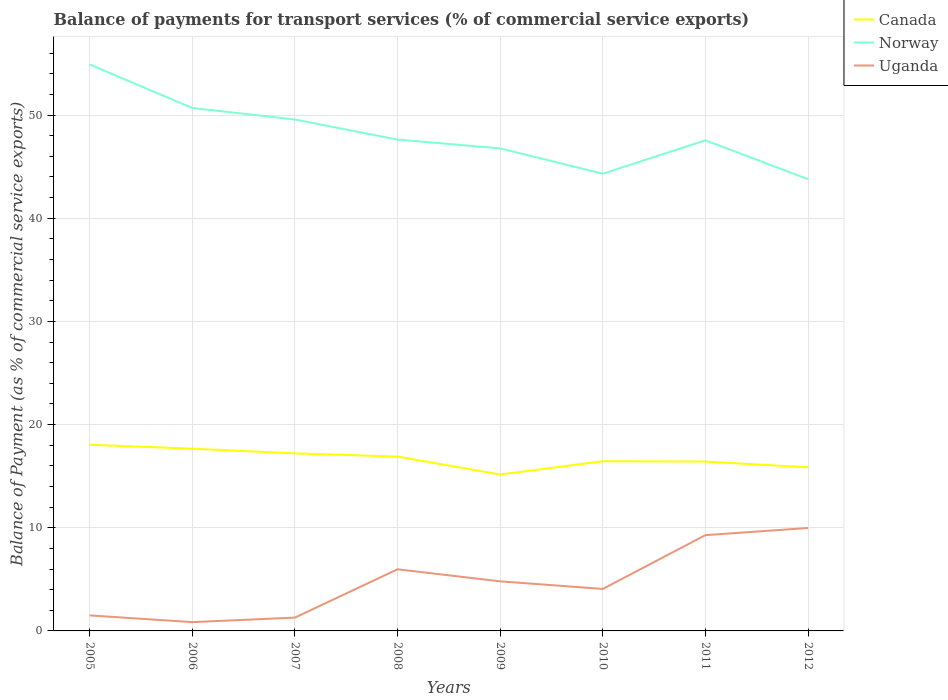Is the number of lines equal to the number of legend labels?
Offer a terse response. Yes. Across all years, what is the maximum balance of payments for transport services in Uganda?
Give a very brief answer. 0.85. In which year was the balance of payments for transport services in Norway maximum?
Provide a short and direct response. 2012. What is the total balance of payments for transport services in Norway in the graph?
Provide a short and direct response. 11.12. What is the difference between the highest and the second highest balance of payments for transport services in Norway?
Your answer should be very brief. 11.12. What is the difference between the highest and the lowest balance of payments for transport services in Uganda?
Offer a very short reply. 4. Is the balance of payments for transport services in Canada strictly greater than the balance of payments for transport services in Uganda over the years?
Provide a short and direct response. No. How many years are there in the graph?
Make the answer very short. 8. What is the difference between two consecutive major ticks on the Y-axis?
Make the answer very short. 10. How are the legend labels stacked?
Your response must be concise. Vertical. What is the title of the graph?
Provide a succinct answer. Balance of payments for transport services (% of commercial service exports). What is the label or title of the X-axis?
Offer a terse response. Years. What is the label or title of the Y-axis?
Your answer should be very brief. Balance of Payment (as % of commercial service exports). What is the Balance of Payment (as % of commercial service exports) of Canada in 2005?
Your answer should be very brief. 18.05. What is the Balance of Payment (as % of commercial service exports) in Norway in 2005?
Offer a terse response. 54.91. What is the Balance of Payment (as % of commercial service exports) in Uganda in 2005?
Give a very brief answer. 1.51. What is the Balance of Payment (as % of commercial service exports) of Canada in 2006?
Your answer should be compact. 17.66. What is the Balance of Payment (as % of commercial service exports) in Norway in 2006?
Provide a short and direct response. 50.69. What is the Balance of Payment (as % of commercial service exports) in Uganda in 2006?
Offer a very short reply. 0.85. What is the Balance of Payment (as % of commercial service exports) in Canada in 2007?
Your answer should be very brief. 17.21. What is the Balance of Payment (as % of commercial service exports) of Norway in 2007?
Your answer should be very brief. 49.57. What is the Balance of Payment (as % of commercial service exports) of Uganda in 2007?
Offer a very short reply. 1.29. What is the Balance of Payment (as % of commercial service exports) of Canada in 2008?
Your answer should be very brief. 16.9. What is the Balance of Payment (as % of commercial service exports) of Norway in 2008?
Provide a succinct answer. 47.63. What is the Balance of Payment (as % of commercial service exports) of Uganda in 2008?
Make the answer very short. 5.97. What is the Balance of Payment (as % of commercial service exports) in Canada in 2009?
Give a very brief answer. 15.16. What is the Balance of Payment (as % of commercial service exports) of Norway in 2009?
Provide a succinct answer. 46.77. What is the Balance of Payment (as % of commercial service exports) in Uganda in 2009?
Your response must be concise. 4.81. What is the Balance of Payment (as % of commercial service exports) of Canada in 2010?
Provide a short and direct response. 16.45. What is the Balance of Payment (as % of commercial service exports) in Norway in 2010?
Make the answer very short. 44.32. What is the Balance of Payment (as % of commercial service exports) in Uganda in 2010?
Give a very brief answer. 4.07. What is the Balance of Payment (as % of commercial service exports) in Canada in 2011?
Offer a very short reply. 16.42. What is the Balance of Payment (as % of commercial service exports) in Norway in 2011?
Offer a terse response. 47.55. What is the Balance of Payment (as % of commercial service exports) of Uganda in 2011?
Your answer should be very brief. 9.28. What is the Balance of Payment (as % of commercial service exports) of Canada in 2012?
Keep it short and to the point. 15.86. What is the Balance of Payment (as % of commercial service exports) of Norway in 2012?
Provide a succinct answer. 43.79. What is the Balance of Payment (as % of commercial service exports) of Uganda in 2012?
Ensure brevity in your answer.  9.98. Across all years, what is the maximum Balance of Payment (as % of commercial service exports) in Canada?
Provide a short and direct response. 18.05. Across all years, what is the maximum Balance of Payment (as % of commercial service exports) in Norway?
Your answer should be compact. 54.91. Across all years, what is the maximum Balance of Payment (as % of commercial service exports) of Uganda?
Your answer should be very brief. 9.98. Across all years, what is the minimum Balance of Payment (as % of commercial service exports) of Canada?
Provide a short and direct response. 15.16. Across all years, what is the minimum Balance of Payment (as % of commercial service exports) of Norway?
Make the answer very short. 43.79. Across all years, what is the minimum Balance of Payment (as % of commercial service exports) in Uganda?
Keep it short and to the point. 0.85. What is the total Balance of Payment (as % of commercial service exports) of Canada in the graph?
Make the answer very short. 133.71. What is the total Balance of Payment (as % of commercial service exports) in Norway in the graph?
Offer a very short reply. 385.22. What is the total Balance of Payment (as % of commercial service exports) of Uganda in the graph?
Provide a short and direct response. 37.76. What is the difference between the Balance of Payment (as % of commercial service exports) in Canada in 2005 and that in 2006?
Your answer should be very brief. 0.39. What is the difference between the Balance of Payment (as % of commercial service exports) in Norway in 2005 and that in 2006?
Offer a terse response. 4.22. What is the difference between the Balance of Payment (as % of commercial service exports) of Uganda in 2005 and that in 2006?
Give a very brief answer. 0.65. What is the difference between the Balance of Payment (as % of commercial service exports) in Canada in 2005 and that in 2007?
Provide a succinct answer. 0.84. What is the difference between the Balance of Payment (as % of commercial service exports) of Norway in 2005 and that in 2007?
Your response must be concise. 5.33. What is the difference between the Balance of Payment (as % of commercial service exports) of Uganda in 2005 and that in 2007?
Keep it short and to the point. 0.21. What is the difference between the Balance of Payment (as % of commercial service exports) in Canada in 2005 and that in 2008?
Ensure brevity in your answer.  1.15. What is the difference between the Balance of Payment (as % of commercial service exports) of Norway in 2005 and that in 2008?
Make the answer very short. 7.28. What is the difference between the Balance of Payment (as % of commercial service exports) of Uganda in 2005 and that in 2008?
Offer a terse response. -4.47. What is the difference between the Balance of Payment (as % of commercial service exports) in Canada in 2005 and that in 2009?
Provide a succinct answer. 2.89. What is the difference between the Balance of Payment (as % of commercial service exports) of Norway in 2005 and that in 2009?
Your answer should be compact. 8.13. What is the difference between the Balance of Payment (as % of commercial service exports) in Uganda in 2005 and that in 2009?
Offer a very short reply. -3.3. What is the difference between the Balance of Payment (as % of commercial service exports) in Canada in 2005 and that in 2010?
Make the answer very short. 1.6. What is the difference between the Balance of Payment (as % of commercial service exports) of Norway in 2005 and that in 2010?
Offer a terse response. 10.59. What is the difference between the Balance of Payment (as % of commercial service exports) in Uganda in 2005 and that in 2010?
Provide a short and direct response. -2.56. What is the difference between the Balance of Payment (as % of commercial service exports) of Canada in 2005 and that in 2011?
Keep it short and to the point. 1.63. What is the difference between the Balance of Payment (as % of commercial service exports) of Norway in 2005 and that in 2011?
Your answer should be compact. 7.35. What is the difference between the Balance of Payment (as % of commercial service exports) in Uganda in 2005 and that in 2011?
Offer a terse response. -7.78. What is the difference between the Balance of Payment (as % of commercial service exports) in Canada in 2005 and that in 2012?
Make the answer very short. 2.19. What is the difference between the Balance of Payment (as % of commercial service exports) in Norway in 2005 and that in 2012?
Keep it short and to the point. 11.12. What is the difference between the Balance of Payment (as % of commercial service exports) in Uganda in 2005 and that in 2012?
Your answer should be compact. -8.47. What is the difference between the Balance of Payment (as % of commercial service exports) of Canada in 2006 and that in 2007?
Offer a very short reply. 0.45. What is the difference between the Balance of Payment (as % of commercial service exports) in Norway in 2006 and that in 2007?
Offer a very short reply. 1.12. What is the difference between the Balance of Payment (as % of commercial service exports) in Uganda in 2006 and that in 2007?
Ensure brevity in your answer.  -0.44. What is the difference between the Balance of Payment (as % of commercial service exports) of Canada in 2006 and that in 2008?
Provide a short and direct response. 0.76. What is the difference between the Balance of Payment (as % of commercial service exports) of Norway in 2006 and that in 2008?
Your answer should be compact. 3.06. What is the difference between the Balance of Payment (as % of commercial service exports) in Uganda in 2006 and that in 2008?
Your response must be concise. -5.12. What is the difference between the Balance of Payment (as % of commercial service exports) in Canada in 2006 and that in 2009?
Provide a succinct answer. 2.5. What is the difference between the Balance of Payment (as % of commercial service exports) in Norway in 2006 and that in 2009?
Make the answer very short. 3.92. What is the difference between the Balance of Payment (as % of commercial service exports) in Uganda in 2006 and that in 2009?
Give a very brief answer. -3.95. What is the difference between the Balance of Payment (as % of commercial service exports) in Canada in 2006 and that in 2010?
Your answer should be compact. 1.21. What is the difference between the Balance of Payment (as % of commercial service exports) of Norway in 2006 and that in 2010?
Provide a short and direct response. 6.37. What is the difference between the Balance of Payment (as % of commercial service exports) of Uganda in 2006 and that in 2010?
Your answer should be compact. -3.22. What is the difference between the Balance of Payment (as % of commercial service exports) of Canada in 2006 and that in 2011?
Make the answer very short. 1.25. What is the difference between the Balance of Payment (as % of commercial service exports) of Norway in 2006 and that in 2011?
Ensure brevity in your answer.  3.13. What is the difference between the Balance of Payment (as % of commercial service exports) in Uganda in 2006 and that in 2011?
Your response must be concise. -8.43. What is the difference between the Balance of Payment (as % of commercial service exports) of Canada in 2006 and that in 2012?
Your answer should be very brief. 1.8. What is the difference between the Balance of Payment (as % of commercial service exports) in Norway in 2006 and that in 2012?
Make the answer very short. 6.9. What is the difference between the Balance of Payment (as % of commercial service exports) in Uganda in 2006 and that in 2012?
Provide a short and direct response. -9.13. What is the difference between the Balance of Payment (as % of commercial service exports) of Canada in 2007 and that in 2008?
Ensure brevity in your answer.  0.31. What is the difference between the Balance of Payment (as % of commercial service exports) of Norway in 2007 and that in 2008?
Offer a terse response. 1.94. What is the difference between the Balance of Payment (as % of commercial service exports) in Uganda in 2007 and that in 2008?
Make the answer very short. -4.68. What is the difference between the Balance of Payment (as % of commercial service exports) of Canada in 2007 and that in 2009?
Your answer should be very brief. 2.05. What is the difference between the Balance of Payment (as % of commercial service exports) in Norway in 2007 and that in 2009?
Provide a succinct answer. 2.8. What is the difference between the Balance of Payment (as % of commercial service exports) of Uganda in 2007 and that in 2009?
Provide a short and direct response. -3.52. What is the difference between the Balance of Payment (as % of commercial service exports) of Canada in 2007 and that in 2010?
Your answer should be compact. 0.76. What is the difference between the Balance of Payment (as % of commercial service exports) of Norway in 2007 and that in 2010?
Your response must be concise. 5.25. What is the difference between the Balance of Payment (as % of commercial service exports) of Uganda in 2007 and that in 2010?
Make the answer very short. -2.78. What is the difference between the Balance of Payment (as % of commercial service exports) of Canada in 2007 and that in 2011?
Keep it short and to the point. 0.79. What is the difference between the Balance of Payment (as % of commercial service exports) in Norway in 2007 and that in 2011?
Give a very brief answer. 2.02. What is the difference between the Balance of Payment (as % of commercial service exports) of Uganda in 2007 and that in 2011?
Make the answer very short. -7.99. What is the difference between the Balance of Payment (as % of commercial service exports) of Canada in 2007 and that in 2012?
Your answer should be compact. 1.35. What is the difference between the Balance of Payment (as % of commercial service exports) of Norway in 2007 and that in 2012?
Make the answer very short. 5.78. What is the difference between the Balance of Payment (as % of commercial service exports) in Uganda in 2007 and that in 2012?
Your answer should be very brief. -8.69. What is the difference between the Balance of Payment (as % of commercial service exports) in Canada in 2008 and that in 2009?
Keep it short and to the point. 1.74. What is the difference between the Balance of Payment (as % of commercial service exports) in Norway in 2008 and that in 2009?
Provide a succinct answer. 0.86. What is the difference between the Balance of Payment (as % of commercial service exports) in Uganda in 2008 and that in 2009?
Provide a succinct answer. 1.17. What is the difference between the Balance of Payment (as % of commercial service exports) of Canada in 2008 and that in 2010?
Provide a succinct answer. 0.45. What is the difference between the Balance of Payment (as % of commercial service exports) in Norway in 2008 and that in 2010?
Ensure brevity in your answer.  3.31. What is the difference between the Balance of Payment (as % of commercial service exports) of Uganda in 2008 and that in 2010?
Make the answer very short. 1.9. What is the difference between the Balance of Payment (as % of commercial service exports) of Canada in 2008 and that in 2011?
Keep it short and to the point. 0.48. What is the difference between the Balance of Payment (as % of commercial service exports) in Norway in 2008 and that in 2011?
Ensure brevity in your answer.  0.08. What is the difference between the Balance of Payment (as % of commercial service exports) in Uganda in 2008 and that in 2011?
Offer a terse response. -3.31. What is the difference between the Balance of Payment (as % of commercial service exports) of Canada in 2008 and that in 2012?
Ensure brevity in your answer.  1.04. What is the difference between the Balance of Payment (as % of commercial service exports) of Norway in 2008 and that in 2012?
Offer a very short reply. 3.84. What is the difference between the Balance of Payment (as % of commercial service exports) of Uganda in 2008 and that in 2012?
Your response must be concise. -4. What is the difference between the Balance of Payment (as % of commercial service exports) in Canada in 2009 and that in 2010?
Your answer should be very brief. -1.29. What is the difference between the Balance of Payment (as % of commercial service exports) in Norway in 2009 and that in 2010?
Give a very brief answer. 2.45. What is the difference between the Balance of Payment (as % of commercial service exports) of Uganda in 2009 and that in 2010?
Provide a succinct answer. 0.74. What is the difference between the Balance of Payment (as % of commercial service exports) of Canada in 2009 and that in 2011?
Your answer should be very brief. -1.25. What is the difference between the Balance of Payment (as % of commercial service exports) in Norway in 2009 and that in 2011?
Your answer should be very brief. -0.78. What is the difference between the Balance of Payment (as % of commercial service exports) in Uganda in 2009 and that in 2011?
Provide a short and direct response. -4.48. What is the difference between the Balance of Payment (as % of commercial service exports) of Canada in 2009 and that in 2012?
Your answer should be very brief. -0.69. What is the difference between the Balance of Payment (as % of commercial service exports) in Norway in 2009 and that in 2012?
Your answer should be compact. 2.98. What is the difference between the Balance of Payment (as % of commercial service exports) of Uganda in 2009 and that in 2012?
Make the answer very short. -5.17. What is the difference between the Balance of Payment (as % of commercial service exports) in Canada in 2010 and that in 2011?
Your answer should be very brief. 0.03. What is the difference between the Balance of Payment (as % of commercial service exports) in Norway in 2010 and that in 2011?
Provide a short and direct response. -3.24. What is the difference between the Balance of Payment (as % of commercial service exports) in Uganda in 2010 and that in 2011?
Provide a succinct answer. -5.21. What is the difference between the Balance of Payment (as % of commercial service exports) of Canada in 2010 and that in 2012?
Give a very brief answer. 0.59. What is the difference between the Balance of Payment (as % of commercial service exports) of Norway in 2010 and that in 2012?
Give a very brief answer. 0.53. What is the difference between the Balance of Payment (as % of commercial service exports) in Uganda in 2010 and that in 2012?
Keep it short and to the point. -5.91. What is the difference between the Balance of Payment (as % of commercial service exports) in Canada in 2011 and that in 2012?
Keep it short and to the point. 0.56. What is the difference between the Balance of Payment (as % of commercial service exports) of Norway in 2011 and that in 2012?
Provide a short and direct response. 3.76. What is the difference between the Balance of Payment (as % of commercial service exports) of Uganda in 2011 and that in 2012?
Give a very brief answer. -0.69. What is the difference between the Balance of Payment (as % of commercial service exports) of Canada in 2005 and the Balance of Payment (as % of commercial service exports) of Norway in 2006?
Keep it short and to the point. -32.64. What is the difference between the Balance of Payment (as % of commercial service exports) of Canada in 2005 and the Balance of Payment (as % of commercial service exports) of Uganda in 2006?
Give a very brief answer. 17.2. What is the difference between the Balance of Payment (as % of commercial service exports) of Norway in 2005 and the Balance of Payment (as % of commercial service exports) of Uganda in 2006?
Your response must be concise. 54.05. What is the difference between the Balance of Payment (as % of commercial service exports) of Canada in 2005 and the Balance of Payment (as % of commercial service exports) of Norway in 2007?
Give a very brief answer. -31.52. What is the difference between the Balance of Payment (as % of commercial service exports) of Canada in 2005 and the Balance of Payment (as % of commercial service exports) of Uganda in 2007?
Make the answer very short. 16.76. What is the difference between the Balance of Payment (as % of commercial service exports) in Norway in 2005 and the Balance of Payment (as % of commercial service exports) in Uganda in 2007?
Offer a very short reply. 53.61. What is the difference between the Balance of Payment (as % of commercial service exports) in Canada in 2005 and the Balance of Payment (as % of commercial service exports) in Norway in 2008?
Your answer should be very brief. -29.58. What is the difference between the Balance of Payment (as % of commercial service exports) in Canada in 2005 and the Balance of Payment (as % of commercial service exports) in Uganda in 2008?
Make the answer very short. 12.08. What is the difference between the Balance of Payment (as % of commercial service exports) of Norway in 2005 and the Balance of Payment (as % of commercial service exports) of Uganda in 2008?
Provide a succinct answer. 48.93. What is the difference between the Balance of Payment (as % of commercial service exports) in Canada in 2005 and the Balance of Payment (as % of commercial service exports) in Norway in 2009?
Provide a short and direct response. -28.72. What is the difference between the Balance of Payment (as % of commercial service exports) of Canada in 2005 and the Balance of Payment (as % of commercial service exports) of Uganda in 2009?
Make the answer very short. 13.24. What is the difference between the Balance of Payment (as % of commercial service exports) of Norway in 2005 and the Balance of Payment (as % of commercial service exports) of Uganda in 2009?
Keep it short and to the point. 50.1. What is the difference between the Balance of Payment (as % of commercial service exports) of Canada in 2005 and the Balance of Payment (as % of commercial service exports) of Norway in 2010?
Provide a succinct answer. -26.27. What is the difference between the Balance of Payment (as % of commercial service exports) in Canada in 2005 and the Balance of Payment (as % of commercial service exports) in Uganda in 2010?
Ensure brevity in your answer.  13.98. What is the difference between the Balance of Payment (as % of commercial service exports) in Norway in 2005 and the Balance of Payment (as % of commercial service exports) in Uganda in 2010?
Ensure brevity in your answer.  50.84. What is the difference between the Balance of Payment (as % of commercial service exports) in Canada in 2005 and the Balance of Payment (as % of commercial service exports) in Norway in 2011?
Provide a succinct answer. -29.5. What is the difference between the Balance of Payment (as % of commercial service exports) in Canada in 2005 and the Balance of Payment (as % of commercial service exports) in Uganda in 2011?
Offer a very short reply. 8.77. What is the difference between the Balance of Payment (as % of commercial service exports) in Norway in 2005 and the Balance of Payment (as % of commercial service exports) in Uganda in 2011?
Give a very brief answer. 45.62. What is the difference between the Balance of Payment (as % of commercial service exports) of Canada in 2005 and the Balance of Payment (as % of commercial service exports) of Norway in 2012?
Offer a terse response. -25.74. What is the difference between the Balance of Payment (as % of commercial service exports) in Canada in 2005 and the Balance of Payment (as % of commercial service exports) in Uganda in 2012?
Offer a very short reply. 8.07. What is the difference between the Balance of Payment (as % of commercial service exports) in Norway in 2005 and the Balance of Payment (as % of commercial service exports) in Uganda in 2012?
Your response must be concise. 44.93. What is the difference between the Balance of Payment (as % of commercial service exports) in Canada in 2006 and the Balance of Payment (as % of commercial service exports) in Norway in 2007?
Provide a short and direct response. -31.91. What is the difference between the Balance of Payment (as % of commercial service exports) in Canada in 2006 and the Balance of Payment (as % of commercial service exports) in Uganda in 2007?
Offer a terse response. 16.37. What is the difference between the Balance of Payment (as % of commercial service exports) of Norway in 2006 and the Balance of Payment (as % of commercial service exports) of Uganda in 2007?
Give a very brief answer. 49.4. What is the difference between the Balance of Payment (as % of commercial service exports) of Canada in 2006 and the Balance of Payment (as % of commercial service exports) of Norway in 2008?
Your answer should be compact. -29.97. What is the difference between the Balance of Payment (as % of commercial service exports) of Canada in 2006 and the Balance of Payment (as % of commercial service exports) of Uganda in 2008?
Your answer should be compact. 11.69. What is the difference between the Balance of Payment (as % of commercial service exports) in Norway in 2006 and the Balance of Payment (as % of commercial service exports) in Uganda in 2008?
Your answer should be very brief. 44.71. What is the difference between the Balance of Payment (as % of commercial service exports) of Canada in 2006 and the Balance of Payment (as % of commercial service exports) of Norway in 2009?
Keep it short and to the point. -29.11. What is the difference between the Balance of Payment (as % of commercial service exports) in Canada in 2006 and the Balance of Payment (as % of commercial service exports) in Uganda in 2009?
Offer a terse response. 12.86. What is the difference between the Balance of Payment (as % of commercial service exports) in Norway in 2006 and the Balance of Payment (as % of commercial service exports) in Uganda in 2009?
Your response must be concise. 45.88. What is the difference between the Balance of Payment (as % of commercial service exports) of Canada in 2006 and the Balance of Payment (as % of commercial service exports) of Norway in 2010?
Offer a terse response. -26.65. What is the difference between the Balance of Payment (as % of commercial service exports) in Canada in 2006 and the Balance of Payment (as % of commercial service exports) in Uganda in 2010?
Offer a very short reply. 13.59. What is the difference between the Balance of Payment (as % of commercial service exports) in Norway in 2006 and the Balance of Payment (as % of commercial service exports) in Uganda in 2010?
Ensure brevity in your answer.  46.62. What is the difference between the Balance of Payment (as % of commercial service exports) in Canada in 2006 and the Balance of Payment (as % of commercial service exports) in Norway in 2011?
Ensure brevity in your answer.  -29.89. What is the difference between the Balance of Payment (as % of commercial service exports) in Canada in 2006 and the Balance of Payment (as % of commercial service exports) in Uganda in 2011?
Make the answer very short. 8.38. What is the difference between the Balance of Payment (as % of commercial service exports) in Norway in 2006 and the Balance of Payment (as % of commercial service exports) in Uganda in 2011?
Make the answer very short. 41.4. What is the difference between the Balance of Payment (as % of commercial service exports) of Canada in 2006 and the Balance of Payment (as % of commercial service exports) of Norway in 2012?
Your answer should be very brief. -26.13. What is the difference between the Balance of Payment (as % of commercial service exports) in Canada in 2006 and the Balance of Payment (as % of commercial service exports) in Uganda in 2012?
Provide a succinct answer. 7.68. What is the difference between the Balance of Payment (as % of commercial service exports) in Norway in 2006 and the Balance of Payment (as % of commercial service exports) in Uganda in 2012?
Ensure brevity in your answer.  40.71. What is the difference between the Balance of Payment (as % of commercial service exports) in Canada in 2007 and the Balance of Payment (as % of commercial service exports) in Norway in 2008?
Offer a terse response. -30.42. What is the difference between the Balance of Payment (as % of commercial service exports) of Canada in 2007 and the Balance of Payment (as % of commercial service exports) of Uganda in 2008?
Offer a terse response. 11.24. What is the difference between the Balance of Payment (as % of commercial service exports) of Norway in 2007 and the Balance of Payment (as % of commercial service exports) of Uganda in 2008?
Provide a succinct answer. 43.6. What is the difference between the Balance of Payment (as % of commercial service exports) of Canada in 2007 and the Balance of Payment (as % of commercial service exports) of Norway in 2009?
Offer a terse response. -29.56. What is the difference between the Balance of Payment (as % of commercial service exports) in Canada in 2007 and the Balance of Payment (as % of commercial service exports) in Uganda in 2009?
Provide a succinct answer. 12.4. What is the difference between the Balance of Payment (as % of commercial service exports) of Norway in 2007 and the Balance of Payment (as % of commercial service exports) of Uganda in 2009?
Make the answer very short. 44.76. What is the difference between the Balance of Payment (as % of commercial service exports) in Canada in 2007 and the Balance of Payment (as % of commercial service exports) in Norway in 2010?
Make the answer very short. -27.11. What is the difference between the Balance of Payment (as % of commercial service exports) in Canada in 2007 and the Balance of Payment (as % of commercial service exports) in Uganda in 2010?
Offer a terse response. 13.14. What is the difference between the Balance of Payment (as % of commercial service exports) in Norway in 2007 and the Balance of Payment (as % of commercial service exports) in Uganda in 2010?
Make the answer very short. 45.5. What is the difference between the Balance of Payment (as % of commercial service exports) of Canada in 2007 and the Balance of Payment (as % of commercial service exports) of Norway in 2011?
Ensure brevity in your answer.  -30.34. What is the difference between the Balance of Payment (as % of commercial service exports) in Canada in 2007 and the Balance of Payment (as % of commercial service exports) in Uganda in 2011?
Your answer should be very brief. 7.93. What is the difference between the Balance of Payment (as % of commercial service exports) in Norway in 2007 and the Balance of Payment (as % of commercial service exports) in Uganda in 2011?
Provide a succinct answer. 40.29. What is the difference between the Balance of Payment (as % of commercial service exports) of Canada in 2007 and the Balance of Payment (as % of commercial service exports) of Norway in 2012?
Your response must be concise. -26.58. What is the difference between the Balance of Payment (as % of commercial service exports) in Canada in 2007 and the Balance of Payment (as % of commercial service exports) in Uganda in 2012?
Give a very brief answer. 7.23. What is the difference between the Balance of Payment (as % of commercial service exports) in Norway in 2007 and the Balance of Payment (as % of commercial service exports) in Uganda in 2012?
Your answer should be compact. 39.59. What is the difference between the Balance of Payment (as % of commercial service exports) of Canada in 2008 and the Balance of Payment (as % of commercial service exports) of Norway in 2009?
Make the answer very short. -29.87. What is the difference between the Balance of Payment (as % of commercial service exports) of Canada in 2008 and the Balance of Payment (as % of commercial service exports) of Uganda in 2009?
Offer a very short reply. 12.09. What is the difference between the Balance of Payment (as % of commercial service exports) of Norway in 2008 and the Balance of Payment (as % of commercial service exports) of Uganda in 2009?
Provide a short and direct response. 42.82. What is the difference between the Balance of Payment (as % of commercial service exports) in Canada in 2008 and the Balance of Payment (as % of commercial service exports) in Norway in 2010?
Your answer should be compact. -27.42. What is the difference between the Balance of Payment (as % of commercial service exports) of Canada in 2008 and the Balance of Payment (as % of commercial service exports) of Uganda in 2010?
Provide a succinct answer. 12.83. What is the difference between the Balance of Payment (as % of commercial service exports) of Norway in 2008 and the Balance of Payment (as % of commercial service exports) of Uganda in 2010?
Provide a short and direct response. 43.56. What is the difference between the Balance of Payment (as % of commercial service exports) in Canada in 2008 and the Balance of Payment (as % of commercial service exports) in Norway in 2011?
Make the answer very short. -30.65. What is the difference between the Balance of Payment (as % of commercial service exports) of Canada in 2008 and the Balance of Payment (as % of commercial service exports) of Uganda in 2011?
Make the answer very short. 7.62. What is the difference between the Balance of Payment (as % of commercial service exports) of Norway in 2008 and the Balance of Payment (as % of commercial service exports) of Uganda in 2011?
Your response must be concise. 38.34. What is the difference between the Balance of Payment (as % of commercial service exports) in Canada in 2008 and the Balance of Payment (as % of commercial service exports) in Norway in 2012?
Provide a succinct answer. -26.89. What is the difference between the Balance of Payment (as % of commercial service exports) in Canada in 2008 and the Balance of Payment (as % of commercial service exports) in Uganda in 2012?
Provide a short and direct response. 6.92. What is the difference between the Balance of Payment (as % of commercial service exports) of Norway in 2008 and the Balance of Payment (as % of commercial service exports) of Uganda in 2012?
Your answer should be very brief. 37.65. What is the difference between the Balance of Payment (as % of commercial service exports) of Canada in 2009 and the Balance of Payment (as % of commercial service exports) of Norway in 2010?
Provide a succinct answer. -29.15. What is the difference between the Balance of Payment (as % of commercial service exports) of Canada in 2009 and the Balance of Payment (as % of commercial service exports) of Uganda in 2010?
Offer a very short reply. 11.1. What is the difference between the Balance of Payment (as % of commercial service exports) in Norway in 2009 and the Balance of Payment (as % of commercial service exports) in Uganda in 2010?
Provide a succinct answer. 42.7. What is the difference between the Balance of Payment (as % of commercial service exports) of Canada in 2009 and the Balance of Payment (as % of commercial service exports) of Norway in 2011?
Ensure brevity in your answer.  -32.39. What is the difference between the Balance of Payment (as % of commercial service exports) in Canada in 2009 and the Balance of Payment (as % of commercial service exports) in Uganda in 2011?
Your answer should be very brief. 5.88. What is the difference between the Balance of Payment (as % of commercial service exports) of Norway in 2009 and the Balance of Payment (as % of commercial service exports) of Uganda in 2011?
Provide a short and direct response. 37.49. What is the difference between the Balance of Payment (as % of commercial service exports) in Canada in 2009 and the Balance of Payment (as % of commercial service exports) in Norway in 2012?
Your answer should be very brief. -28.63. What is the difference between the Balance of Payment (as % of commercial service exports) in Canada in 2009 and the Balance of Payment (as % of commercial service exports) in Uganda in 2012?
Provide a short and direct response. 5.19. What is the difference between the Balance of Payment (as % of commercial service exports) in Norway in 2009 and the Balance of Payment (as % of commercial service exports) in Uganda in 2012?
Your answer should be compact. 36.79. What is the difference between the Balance of Payment (as % of commercial service exports) in Canada in 2010 and the Balance of Payment (as % of commercial service exports) in Norway in 2011?
Offer a terse response. -31.1. What is the difference between the Balance of Payment (as % of commercial service exports) of Canada in 2010 and the Balance of Payment (as % of commercial service exports) of Uganda in 2011?
Ensure brevity in your answer.  7.17. What is the difference between the Balance of Payment (as % of commercial service exports) in Norway in 2010 and the Balance of Payment (as % of commercial service exports) in Uganda in 2011?
Your answer should be compact. 35.03. What is the difference between the Balance of Payment (as % of commercial service exports) in Canada in 2010 and the Balance of Payment (as % of commercial service exports) in Norway in 2012?
Provide a short and direct response. -27.34. What is the difference between the Balance of Payment (as % of commercial service exports) of Canada in 2010 and the Balance of Payment (as % of commercial service exports) of Uganda in 2012?
Ensure brevity in your answer.  6.47. What is the difference between the Balance of Payment (as % of commercial service exports) in Norway in 2010 and the Balance of Payment (as % of commercial service exports) in Uganda in 2012?
Provide a short and direct response. 34.34. What is the difference between the Balance of Payment (as % of commercial service exports) of Canada in 2011 and the Balance of Payment (as % of commercial service exports) of Norway in 2012?
Your response must be concise. -27.37. What is the difference between the Balance of Payment (as % of commercial service exports) of Canada in 2011 and the Balance of Payment (as % of commercial service exports) of Uganda in 2012?
Offer a very short reply. 6.44. What is the difference between the Balance of Payment (as % of commercial service exports) of Norway in 2011 and the Balance of Payment (as % of commercial service exports) of Uganda in 2012?
Ensure brevity in your answer.  37.58. What is the average Balance of Payment (as % of commercial service exports) in Canada per year?
Your response must be concise. 16.71. What is the average Balance of Payment (as % of commercial service exports) of Norway per year?
Offer a very short reply. 48.15. What is the average Balance of Payment (as % of commercial service exports) of Uganda per year?
Your answer should be compact. 4.72. In the year 2005, what is the difference between the Balance of Payment (as % of commercial service exports) in Canada and Balance of Payment (as % of commercial service exports) in Norway?
Ensure brevity in your answer.  -36.86. In the year 2005, what is the difference between the Balance of Payment (as % of commercial service exports) of Canada and Balance of Payment (as % of commercial service exports) of Uganda?
Ensure brevity in your answer.  16.54. In the year 2005, what is the difference between the Balance of Payment (as % of commercial service exports) of Norway and Balance of Payment (as % of commercial service exports) of Uganda?
Give a very brief answer. 53.4. In the year 2006, what is the difference between the Balance of Payment (as % of commercial service exports) in Canada and Balance of Payment (as % of commercial service exports) in Norway?
Your answer should be very brief. -33.02. In the year 2006, what is the difference between the Balance of Payment (as % of commercial service exports) in Canada and Balance of Payment (as % of commercial service exports) in Uganda?
Make the answer very short. 16.81. In the year 2006, what is the difference between the Balance of Payment (as % of commercial service exports) of Norway and Balance of Payment (as % of commercial service exports) of Uganda?
Offer a terse response. 49.83. In the year 2007, what is the difference between the Balance of Payment (as % of commercial service exports) of Canada and Balance of Payment (as % of commercial service exports) of Norway?
Your response must be concise. -32.36. In the year 2007, what is the difference between the Balance of Payment (as % of commercial service exports) of Canada and Balance of Payment (as % of commercial service exports) of Uganda?
Offer a very short reply. 15.92. In the year 2007, what is the difference between the Balance of Payment (as % of commercial service exports) of Norway and Balance of Payment (as % of commercial service exports) of Uganda?
Keep it short and to the point. 48.28. In the year 2008, what is the difference between the Balance of Payment (as % of commercial service exports) of Canada and Balance of Payment (as % of commercial service exports) of Norway?
Provide a short and direct response. -30.73. In the year 2008, what is the difference between the Balance of Payment (as % of commercial service exports) in Canada and Balance of Payment (as % of commercial service exports) in Uganda?
Your answer should be compact. 10.93. In the year 2008, what is the difference between the Balance of Payment (as % of commercial service exports) in Norway and Balance of Payment (as % of commercial service exports) in Uganda?
Ensure brevity in your answer.  41.65. In the year 2009, what is the difference between the Balance of Payment (as % of commercial service exports) in Canada and Balance of Payment (as % of commercial service exports) in Norway?
Your answer should be compact. -31.61. In the year 2009, what is the difference between the Balance of Payment (as % of commercial service exports) in Canada and Balance of Payment (as % of commercial service exports) in Uganda?
Your response must be concise. 10.36. In the year 2009, what is the difference between the Balance of Payment (as % of commercial service exports) of Norway and Balance of Payment (as % of commercial service exports) of Uganda?
Keep it short and to the point. 41.97. In the year 2010, what is the difference between the Balance of Payment (as % of commercial service exports) in Canada and Balance of Payment (as % of commercial service exports) in Norway?
Provide a succinct answer. -27.87. In the year 2010, what is the difference between the Balance of Payment (as % of commercial service exports) in Canada and Balance of Payment (as % of commercial service exports) in Uganda?
Ensure brevity in your answer.  12.38. In the year 2010, what is the difference between the Balance of Payment (as % of commercial service exports) of Norway and Balance of Payment (as % of commercial service exports) of Uganda?
Make the answer very short. 40.25. In the year 2011, what is the difference between the Balance of Payment (as % of commercial service exports) of Canada and Balance of Payment (as % of commercial service exports) of Norway?
Offer a very short reply. -31.14. In the year 2011, what is the difference between the Balance of Payment (as % of commercial service exports) of Canada and Balance of Payment (as % of commercial service exports) of Uganda?
Provide a short and direct response. 7.13. In the year 2011, what is the difference between the Balance of Payment (as % of commercial service exports) of Norway and Balance of Payment (as % of commercial service exports) of Uganda?
Make the answer very short. 38.27. In the year 2012, what is the difference between the Balance of Payment (as % of commercial service exports) in Canada and Balance of Payment (as % of commercial service exports) in Norway?
Keep it short and to the point. -27.93. In the year 2012, what is the difference between the Balance of Payment (as % of commercial service exports) of Canada and Balance of Payment (as % of commercial service exports) of Uganda?
Give a very brief answer. 5.88. In the year 2012, what is the difference between the Balance of Payment (as % of commercial service exports) of Norway and Balance of Payment (as % of commercial service exports) of Uganda?
Give a very brief answer. 33.81. What is the ratio of the Balance of Payment (as % of commercial service exports) of Canada in 2005 to that in 2006?
Ensure brevity in your answer.  1.02. What is the ratio of the Balance of Payment (as % of commercial service exports) of Norway in 2005 to that in 2006?
Provide a succinct answer. 1.08. What is the ratio of the Balance of Payment (as % of commercial service exports) of Uganda in 2005 to that in 2006?
Provide a short and direct response. 1.77. What is the ratio of the Balance of Payment (as % of commercial service exports) in Canada in 2005 to that in 2007?
Provide a short and direct response. 1.05. What is the ratio of the Balance of Payment (as % of commercial service exports) of Norway in 2005 to that in 2007?
Your answer should be very brief. 1.11. What is the ratio of the Balance of Payment (as % of commercial service exports) of Uganda in 2005 to that in 2007?
Your response must be concise. 1.17. What is the ratio of the Balance of Payment (as % of commercial service exports) in Canada in 2005 to that in 2008?
Give a very brief answer. 1.07. What is the ratio of the Balance of Payment (as % of commercial service exports) of Norway in 2005 to that in 2008?
Keep it short and to the point. 1.15. What is the ratio of the Balance of Payment (as % of commercial service exports) in Uganda in 2005 to that in 2008?
Offer a very short reply. 0.25. What is the ratio of the Balance of Payment (as % of commercial service exports) of Canada in 2005 to that in 2009?
Provide a short and direct response. 1.19. What is the ratio of the Balance of Payment (as % of commercial service exports) of Norway in 2005 to that in 2009?
Your answer should be compact. 1.17. What is the ratio of the Balance of Payment (as % of commercial service exports) of Uganda in 2005 to that in 2009?
Provide a short and direct response. 0.31. What is the ratio of the Balance of Payment (as % of commercial service exports) of Canada in 2005 to that in 2010?
Provide a short and direct response. 1.1. What is the ratio of the Balance of Payment (as % of commercial service exports) in Norway in 2005 to that in 2010?
Provide a short and direct response. 1.24. What is the ratio of the Balance of Payment (as % of commercial service exports) in Uganda in 2005 to that in 2010?
Ensure brevity in your answer.  0.37. What is the ratio of the Balance of Payment (as % of commercial service exports) of Canada in 2005 to that in 2011?
Your answer should be compact. 1.1. What is the ratio of the Balance of Payment (as % of commercial service exports) of Norway in 2005 to that in 2011?
Your response must be concise. 1.15. What is the ratio of the Balance of Payment (as % of commercial service exports) of Uganda in 2005 to that in 2011?
Offer a terse response. 0.16. What is the ratio of the Balance of Payment (as % of commercial service exports) of Canada in 2005 to that in 2012?
Your answer should be compact. 1.14. What is the ratio of the Balance of Payment (as % of commercial service exports) in Norway in 2005 to that in 2012?
Your answer should be compact. 1.25. What is the ratio of the Balance of Payment (as % of commercial service exports) of Uganda in 2005 to that in 2012?
Your answer should be compact. 0.15. What is the ratio of the Balance of Payment (as % of commercial service exports) in Canada in 2006 to that in 2007?
Ensure brevity in your answer.  1.03. What is the ratio of the Balance of Payment (as % of commercial service exports) of Norway in 2006 to that in 2007?
Provide a short and direct response. 1.02. What is the ratio of the Balance of Payment (as % of commercial service exports) in Uganda in 2006 to that in 2007?
Make the answer very short. 0.66. What is the ratio of the Balance of Payment (as % of commercial service exports) of Canada in 2006 to that in 2008?
Keep it short and to the point. 1.05. What is the ratio of the Balance of Payment (as % of commercial service exports) of Norway in 2006 to that in 2008?
Your response must be concise. 1.06. What is the ratio of the Balance of Payment (as % of commercial service exports) of Uganda in 2006 to that in 2008?
Offer a very short reply. 0.14. What is the ratio of the Balance of Payment (as % of commercial service exports) in Canada in 2006 to that in 2009?
Give a very brief answer. 1.16. What is the ratio of the Balance of Payment (as % of commercial service exports) in Norway in 2006 to that in 2009?
Make the answer very short. 1.08. What is the ratio of the Balance of Payment (as % of commercial service exports) in Uganda in 2006 to that in 2009?
Your response must be concise. 0.18. What is the ratio of the Balance of Payment (as % of commercial service exports) of Canada in 2006 to that in 2010?
Provide a succinct answer. 1.07. What is the ratio of the Balance of Payment (as % of commercial service exports) of Norway in 2006 to that in 2010?
Keep it short and to the point. 1.14. What is the ratio of the Balance of Payment (as % of commercial service exports) in Uganda in 2006 to that in 2010?
Keep it short and to the point. 0.21. What is the ratio of the Balance of Payment (as % of commercial service exports) in Canada in 2006 to that in 2011?
Offer a very short reply. 1.08. What is the ratio of the Balance of Payment (as % of commercial service exports) in Norway in 2006 to that in 2011?
Give a very brief answer. 1.07. What is the ratio of the Balance of Payment (as % of commercial service exports) of Uganda in 2006 to that in 2011?
Your answer should be compact. 0.09. What is the ratio of the Balance of Payment (as % of commercial service exports) in Canada in 2006 to that in 2012?
Offer a very short reply. 1.11. What is the ratio of the Balance of Payment (as % of commercial service exports) of Norway in 2006 to that in 2012?
Offer a very short reply. 1.16. What is the ratio of the Balance of Payment (as % of commercial service exports) of Uganda in 2006 to that in 2012?
Keep it short and to the point. 0.09. What is the ratio of the Balance of Payment (as % of commercial service exports) of Canada in 2007 to that in 2008?
Offer a terse response. 1.02. What is the ratio of the Balance of Payment (as % of commercial service exports) of Norway in 2007 to that in 2008?
Your answer should be very brief. 1.04. What is the ratio of the Balance of Payment (as % of commercial service exports) of Uganda in 2007 to that in 2008?
Your response must be concise. 0.22. What is the ratio of the Balance of Payment (as % of commercial service exports) of Canada in 2007 to that in 2009?
Your answer should be compact. 1.13. What is the ratio of the Balance of Payment (as % of commercial service exports) of Norway in 2007 to that in 2009?
Your answer should be compact. 1.06. What is the ratio of the Balance of Payment (as % of commercial service exports) in Uganda in 2007 to that in 2009?
Make the answer very short. 0.27. What is the ratio of the Balance of Payment (as % of commercial service exports) in Canada in 2007 to that in 2010?
Give a very brief answer. 1.05. What is the ratio of the Balance of Payment (as % of commercial service exports) in Norway in 2007 to that in 2010?
Ensure brevity in your answer.  1.12. What is the ratio of the Balance of Payment (as % of commercial service exports) of Uganda in 2007 to that in 2010?
Provide a succinct answer. 0.32. What is the ratio of the Balance of Payment (as % of commercial service exports) of Canada in 2007 to that in 2011?
Keep it short and to the point. 1.05. What is the ratio of the Balance of Payment (as % of commercial service exports) in Norway in 2007 to that in 2011?
Ensure brevity in your answer.  1.04. What is the ratio of the Balance of Payment (as % of commercial service exports) of Uganda in 2007 to that in 2011?
Give a very brief answer. 0.14. What is the ratio of the Balance of Payment (as % of commercial service exports) of Canada in 2007 to that in 2012?
Ensure brevity in your answer.  1.09. What is the ratio of the Balance of Payment (as % of commercial service exports) of Norway in 2007 to that in 2012?
Keep it short and to the point. 1.13. What is the ratio of the Balance of Payment (as % of commercial service exports) of Uganda in 2007 to that in 2012?
Provide a short and direct response. 0.13. What is the ratio of the Balance of Payment (as % of commercial service exports) of Canada in 2008 to that in 2009?
Ensure brevity in your answer.  1.11. What is the ratio of the Balance of Payment (as % of commercial service exports) in Norway in 2008 to that in 2009?
Make the answer very short. 1.02. What is the ratio of the Balance of Payment (as % of commercial service exports) in Uganda in 2008 to that in 2009?
Your answer should be compact. 1.24. What is the ratio of the Balance of Payment (as % of commercial service exports) in Canada in 2008 to that in 2010?
Give a very brief answer. 1.03. What is the ratio of the Balance of Payment (as % of commercial service exports) in Norway in 2008 to that in 2010?
Your response must be concise. 1.07. What is the ratio of the Balance of Payment (as % of commercial service exports) in Uganda in 2008 to that in 2010?
Offer a very short reply. 1.47. What is the ratio of the Balance of Payment (as % of commercial service exports) of Canada in 2008 to that in 2011?
Offer a terse response. 1.03. What is the ratio of the Balance of Payment (as % of commercial service exports) of Norway in 2008 to that in 2011?
Make the answer very short. 1. What is the ratio of the Balance of Payment (as % of commercial service exports) in Uganda in 2008 to that in 2011?
Provide a short and direct response. 0.64. What is the ratio of the Balance of Payment (as % of commercial service exports) in Canada in 2008 to that in 2012?
Your answer should be very brief. 1.07. What is the ratio of the Balance of Payment (as % of commercial service exports) of Norway in 2008 to that in 2012?
Make the answer very short. 1.09. What is the ratio of the Balance of Payment (as % of commercial service exports) of Uganda in 2008 to that in 2012?
Give a very brief answer. 0.6. What is the ratio of the Balance of Payment (as % of commercial service exports) in Canada in 2009 to that in 2010?
Make the answer very short. 0.92. What is the ratio of the Balance of Payment (as % of commercial service exports) of Norway in 2009 to that in 2010?
Ensure brevity in your answer.  1.06. What is the ratio of the Balance of Payment (as % of commercial service exports) in Uganda in 2009 to that in 2010?
Your answer should be very brief. 1.18. What is the ratio of the Balance of Payment (as % of commercial service exports) in Canada in 2009 to that in 2011?
Give a very brief answer. 0.92. What is the ratio of the Balance of Payment (as % of commercial service exports) in Norway in 2009 to that in 2011?
Your response must be concise. 0.98. What is the ratio of the Balance of Payment (as % of commercial service exports) of Uganda in 2009 to that in 2011?
Make the answer very short. 0.52. What is the ratio of the Balance of Payment (as % of commercial service exports) in Canada in 2009 to that in 2012?
Keep it short and to the point. 0.96. What is the ratio of the Balance of Payment (as % of commercial service exports) of Norway in 2009 to that in 2012?
Your answer should be compact. 1.07. What is the ratio of the Balance of Payment (as % of commercial service exports) in Uganda in 2009 to that in 2012?
Ensure brevity in your answer.  0.48. What is the ratio of the Balance of Payment (as % of commercial service exports) of Norway in 2010 to that in 2011?
Provide a short and direct response. 0.93. What is the ratio of the Balance of Payment (as % of commercial service exports) in Uganda in 2010 to that in 2011?
Provide a succinct answer. 0.44. What is the ratio of the Balance of Payment (as % of commercial service exports) of Canada in 2010 to that in 2012?
Make the answer very short. 1.04. What is the ratio of the Balance of Payment (as % of commercial service exports) of Norway in 2010 to that in 2012?
Give a very brief answer. 1.01. What is the ratio of the Balance of Payment (as % of commercial service exports) in Uganda in 2010 to that in 2012?
Your answer should be very brief. 0.41. What is the ratio of the Balance of Payment (as % of commercial service exports) in Canada in 2011 to that in 2012?
Make the answer very short. 1.04. What is the ratio of the Balance of Payment (as % of commercial service exports) in Norway in 2011 to that in 2012?
Give a very brief answer. 1.09. What is the ratio of the Balance of Payment (as % of commercial service exports) of Uganda in 2011 to that in 2012?
Give a very brief answer. 0.93. What is the difference between the highest and the second highest Balance of Payment (as % of commercial service exports) in Canada?
Offer a terse response. 0.39. What is the difference between the highest and the second highest Balance of Payment (as % of commercial service exports) of Norway?
Offer a very short reply. 4.22. What is the difference between the highest and the second highest Balance of Payment (as % of commercial service exports) of Uganda?
Ensure brevity in your answer.  0.69. What is the difference between the highest and the lowest Balance of Payment (as % of commercial service exports) in Canada?
Make the answer very short. 2.89. What is the difference between the highest and the lowest Balance of Payment (as % of commercial service exports) of Norway?
Give a very brief answer. 11.12. What is the difference between the highest and the lowest Balance of Payment (as % of commercial service exports) of Uganda?
Offer a very short reply. 9.13. 